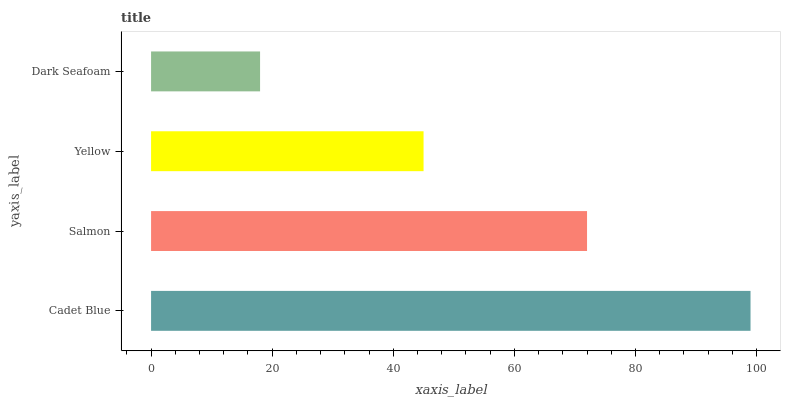Is Dark Seafoam the minimum?
Answer yes or no. Yes. Is Cadet Blue the maximum?
Answer yes or no. Yes. Is Salmon the minimum?
Answer yes or no. No. Is Salmon the maximum?
Answer yes or no. No. Is Cadet Blue greater than Salmon?
Answer yes or no. Yes. Is Salmon less than Cadet Blue?
Answer yes or no. Yes. Is Salmon greater than Cadet Blue?
Answer yes or no. No. Is Cadet Blue less than Salmon?
Answer yes or no. No. Is Salmon the high median?
Answer yes or no. Yes. Is Yellow the low median?
Answer yes or no. Yes. Is Yellow the high median?
Answer yes or no. No. Is Dark Seafoam the low median?
Answer yes or no. No. 